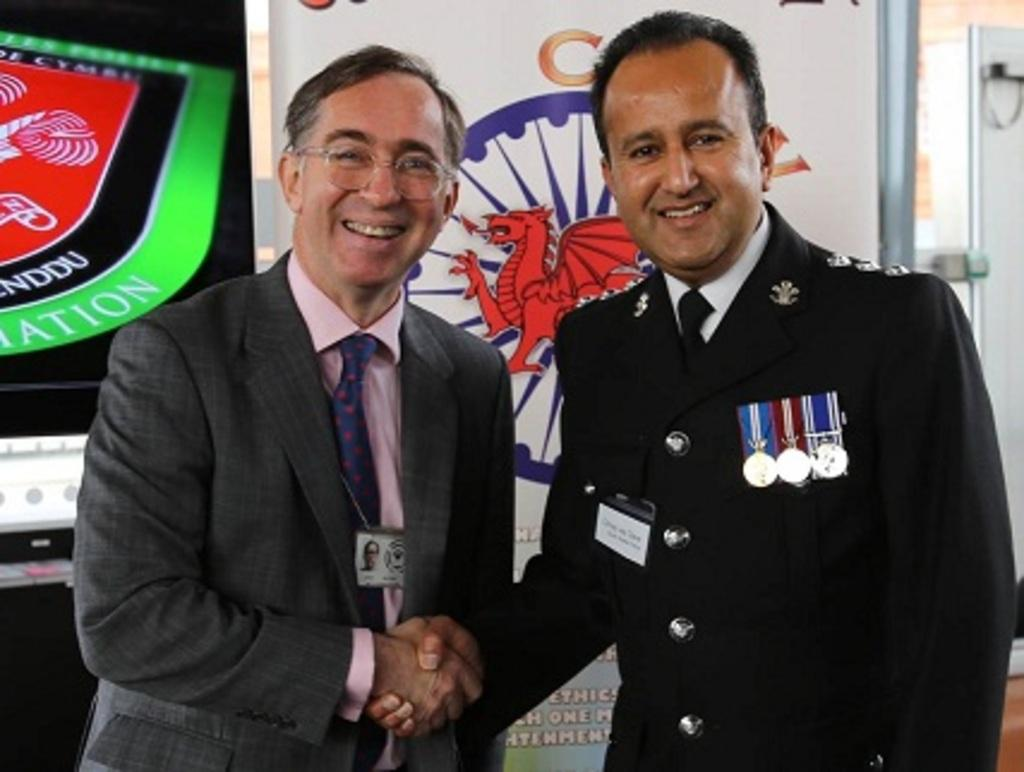How many people are present in the image? There are two people in the image. What is the facial expression of the people in the image? The people are smiling. What can be seen in the background of the image? There are posters and other objects in the background of the image. What type of company is represented by the logo on the person's lip in the image? There is no logo or company mentioned or visible on anyone's lip in the image. 